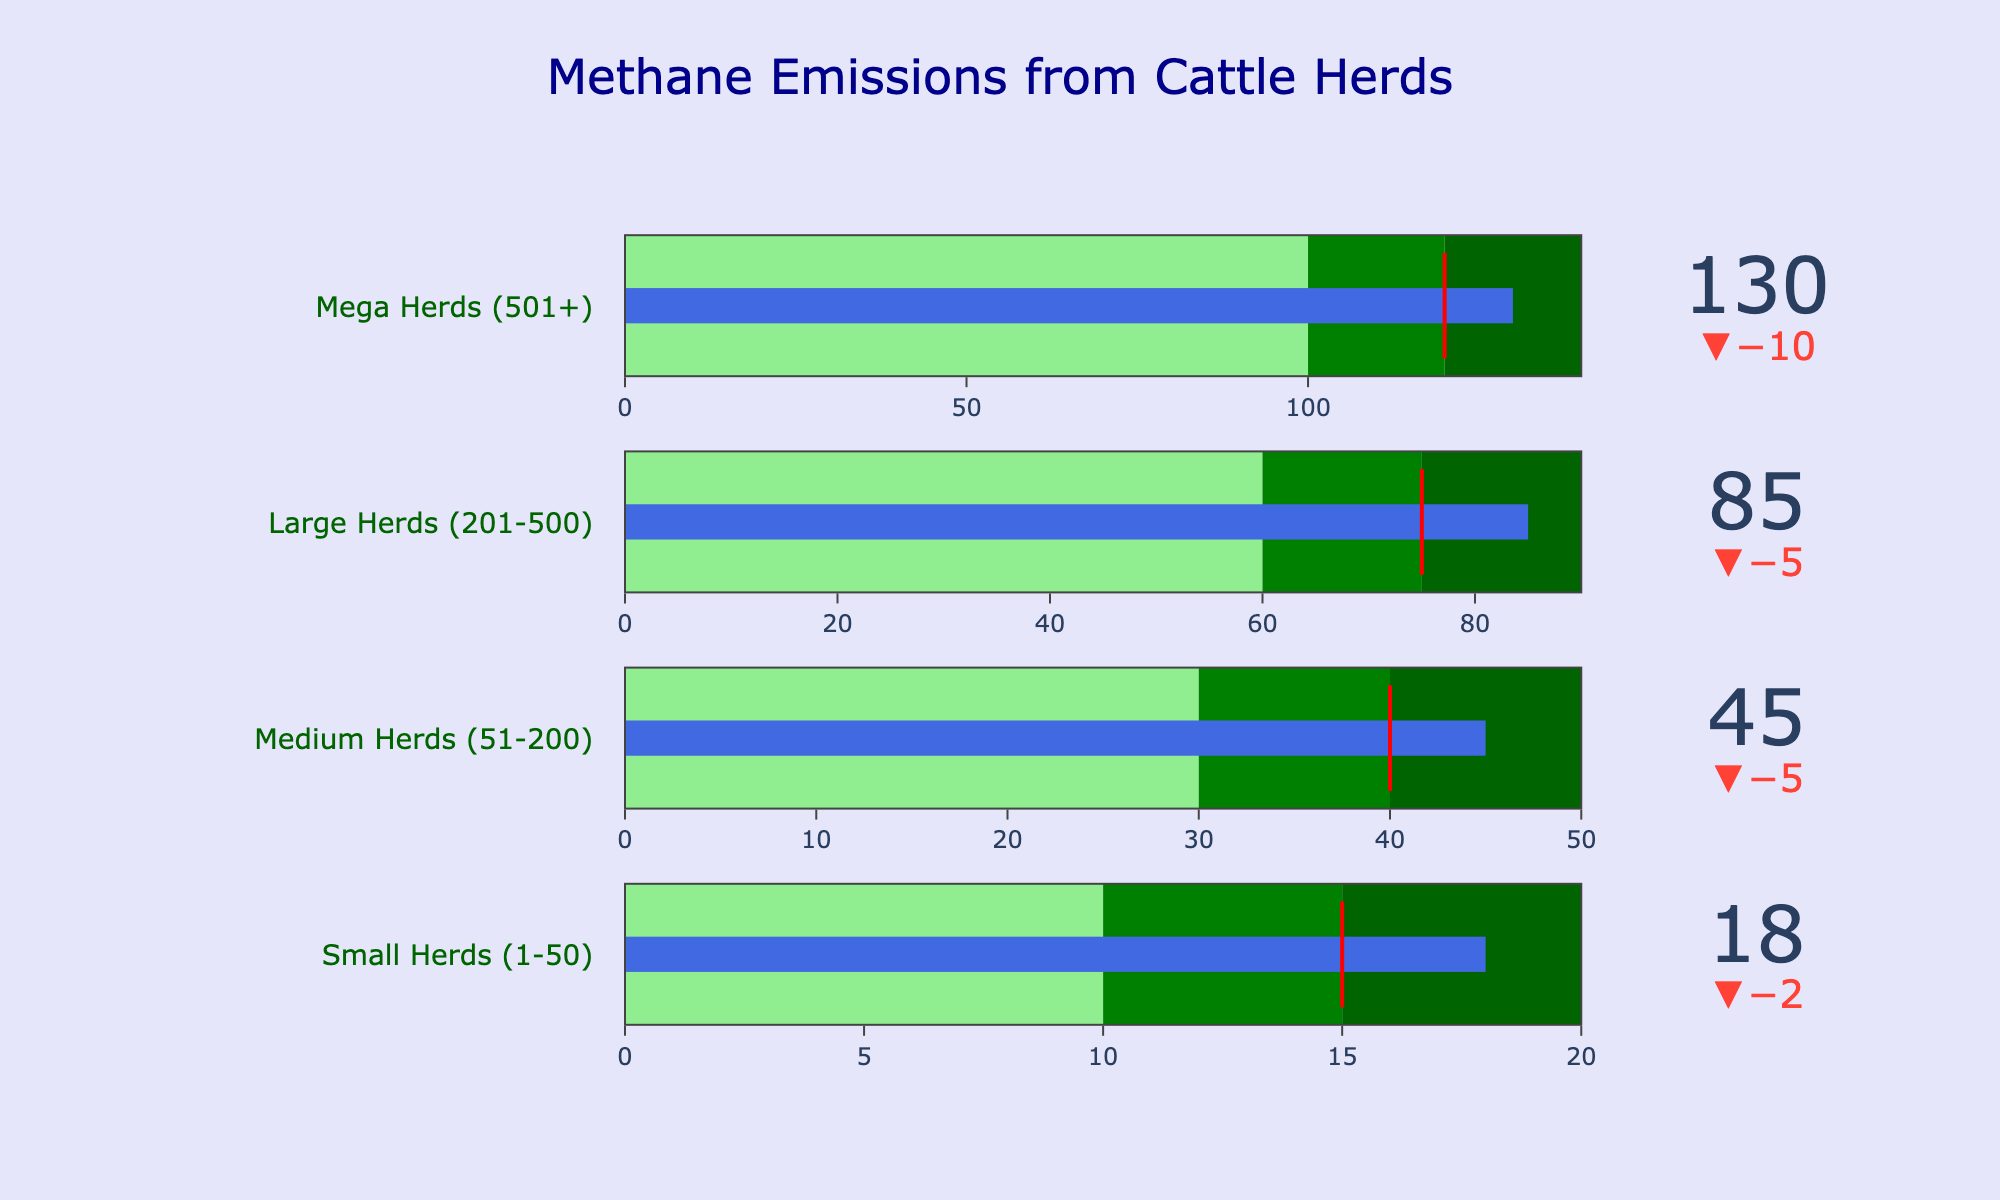What is the actual methane emission for Medium Herds (51-200)? The actual value is indicated by the blue bar specific to the Medium Herds category.
Answer: 45 Which category has the highest target methane emission? By looking at the red threshold lines, the category with the highest target is the Mega Herds (501+).
Answer: Mega Herds (501+) Are the actual methane emissions for Small Herds above the target value? Comparing the actual value of Small Herds (18) to its target (15), we see that it is indeed above the target.
Answer: Yes What is the difference between the comparative and actual emissions for Large Herds? The comparative emission for Large Herds is 90, and the actual emissions are 85. The difference is 90 - 85.
Answer: 5 Which herd size category is closest to meeting its comparative methane emissions? Calculate the differences between actual and comparative emissions for each category and check which is the smallest. Mega Herds (501+) have a difference of 10, which is the smallest among all categories.
Answer: Mega Herds (501+) What is the sum of the target methane emissions of all herd categories? Sum the target values across all categories: 15 (Small) + 40 (Medium) + 75 (Large) + 120 (Mega) = 250.
Answer: 250 In which range does the actual methane emission for Medium Herds fall? The Medium Herds' actual emission is 45, and it falls within the dark green range which is 40 to 50 according to the figure.
Answer: Dark Green How much more methane do Large Herds emit compared to their target? The Large Herds' actual emissions are 85, and the target is 75. The difference is 85 - 75.
Answer: 10 What color represents the steps from 0 to 15 for the Small Herds’ emissions? The color representing the range from 0 to 15 is light green based on the gradient used in the gauge.
Answer: Light green Which herd category exceeds its comparative standard by the largest margin? Calculate the delta for each: Small -2, Medium -5, Large -5, Mega -10. The category with the highest positive delta is Mega Herds (501+).
Answer: None 